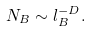Convert formula to latex. <formula><loc_0><loc_0><loc_500><loc_500>N _ { B } \sim l _ { B } ^ { - D } .</formula> 